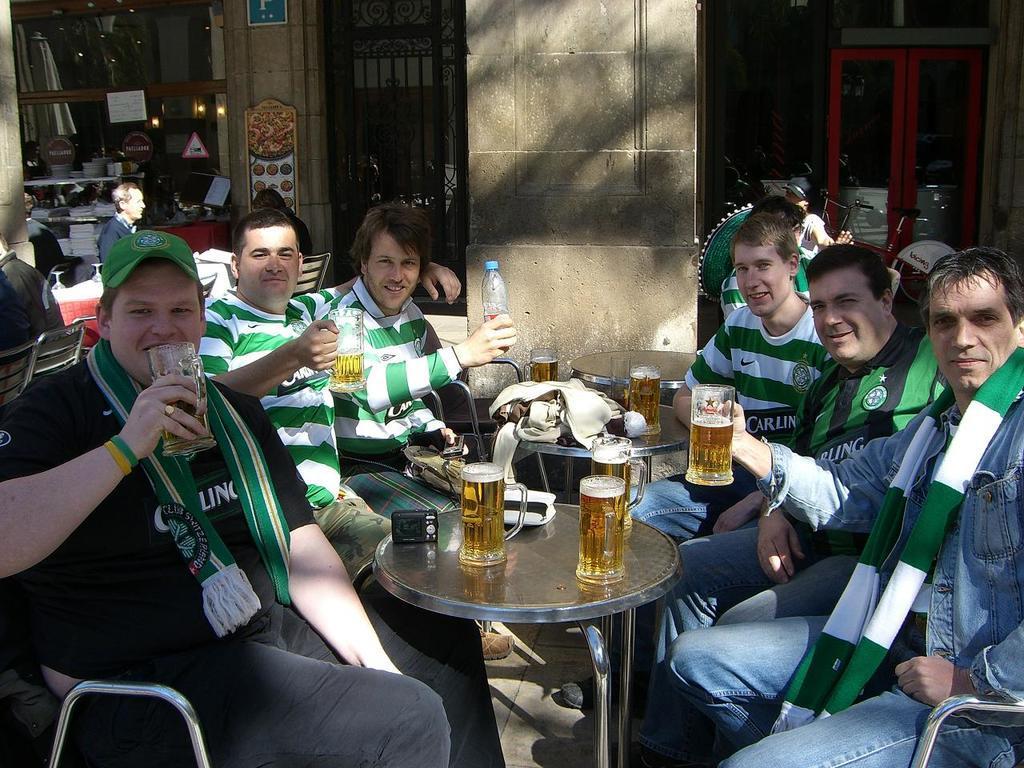Could you give a brief overview of what you see in this image? In this picture we can see group of man some are holding glasses in their hands and bottles and in front of them we have table and on table we can see glasses, sweater, camera and in background we can see door, pillar, books, curtains, sticker, light, sign board. 